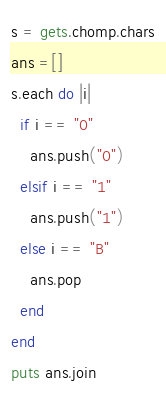Convert code to text. <code><loc_0><loc_0><loc_500><loc_500><_Ruby_>s = gets.chomp.chars
ans =[]
s.each do |i|
  if i == "0"
    ans.push("0")
  elsif i == "1"
    ans.push("1")
  else i == "B"
    ans.pop
  end
end
puts ans.join
</code> 